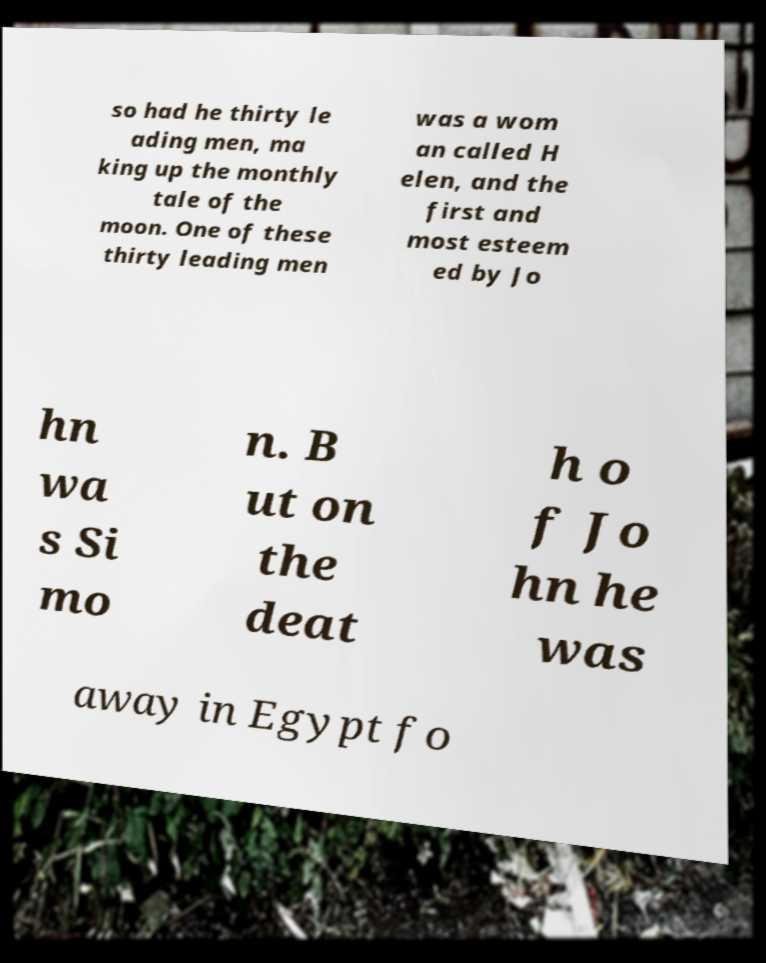Please read and relay the text visible in this image. What does it say? so had he thirty le ading men, ma king up the monthly tale of the moon. One of these thirty leading men was a wom an called H elen, and the first and most esteem ed by Jo hn wa s Si mo n. B ut on the deat h o f Jo hn he was away in Egypt fo 